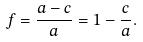<formula> <loc_0><loc_0><loc_500><loc_500>f = { \frac { a - c } { a } } = 1 - { \frac { c } { a } } .</formula> 